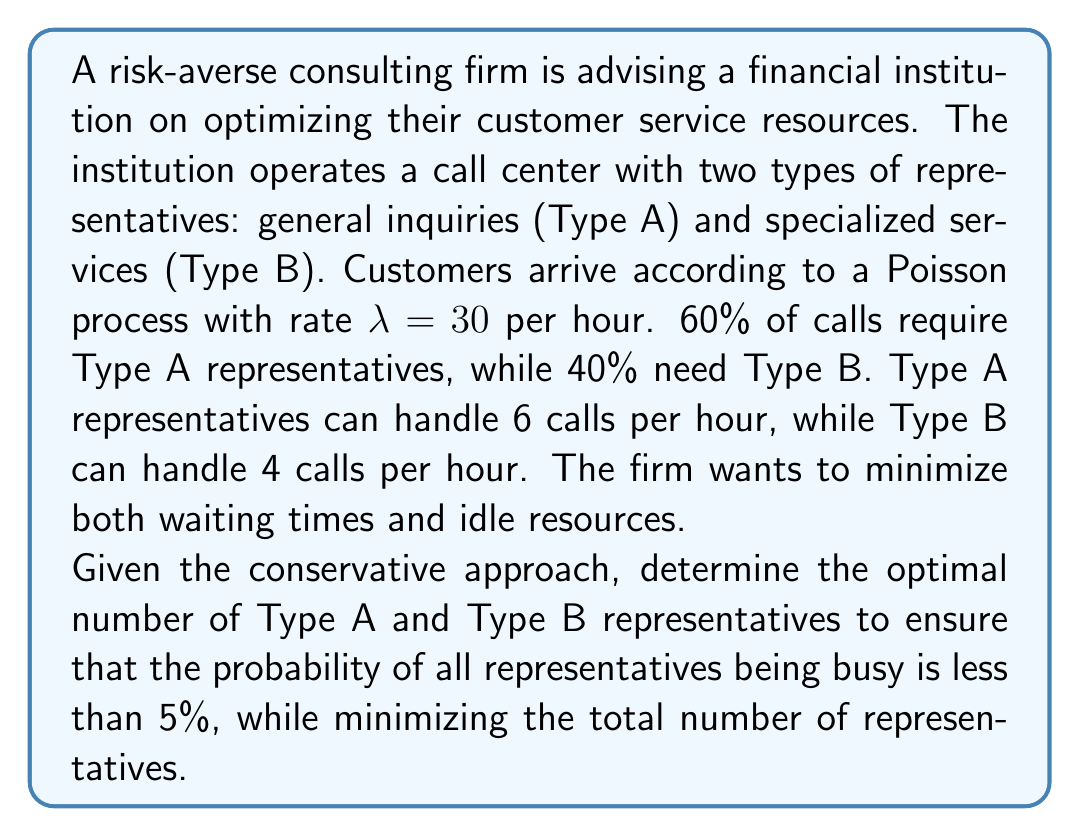Can you answer this question? Let's approach this step-by-step using queuing theory:

1) First, we need to calculate the arrival rates for each type of call:
   Type A: $\lambda_A = 0.60 \times 30 = 18$ calls/hour
   Type B: $\lambda_B = 0.40 \times 30 = 12$ calls/hour

2) Now, let's calculate the service rates:
   Type A: $\mu_A = 6$ calls/hour
   Type B: $\mu_B = 4$ calls/hour

3) We can treat this as two separate M/M/c queues, where c is the number of representatives we need to determine.

4) For each queue, we want to find the smallest c such that the probability of all servers being busy (Erlang C formula) is less than 5%.

5) The Erlang C formula is:

   $$P(W > 0) = \frac{\frac{(c\rho)^c}{c!}(\frac{1}{1-\rho})}{\sum_{n=0}^{c-1}\frac{(c\rho)^n}{n!} + \frac{(c\rho)^c}{c!}(\frac{1}{1-\rho})}$$

   where $\rho = \frac{\lambda}{c\mu}$

6) For Type A:
   $\rho_A = \frac{18}{c_A \times 6}$
   We need to find the smallest $c_A$ such that $P(W > 0) < 0.05$

7) For Type B:
   $\rho_B = \frac{12}{c_B \times 4}$
   We need to find the smallest $c_B$ such that $P(W > 0) < 0.05$

8) Using iterative calculations or a queuing theory calculator, we find:
   $c_A = 5$ (gives $P(W > 0) \approx 0.0499$)
   $c_B = 5$ (gives $P(W > 0) \approx 0.0461$)

9) These values ensure that the probability of all representatives being busy is less than 5% for each type, while minimizing the total number of representatives.
Answer: 5 Type A and 5 Type B representatives 